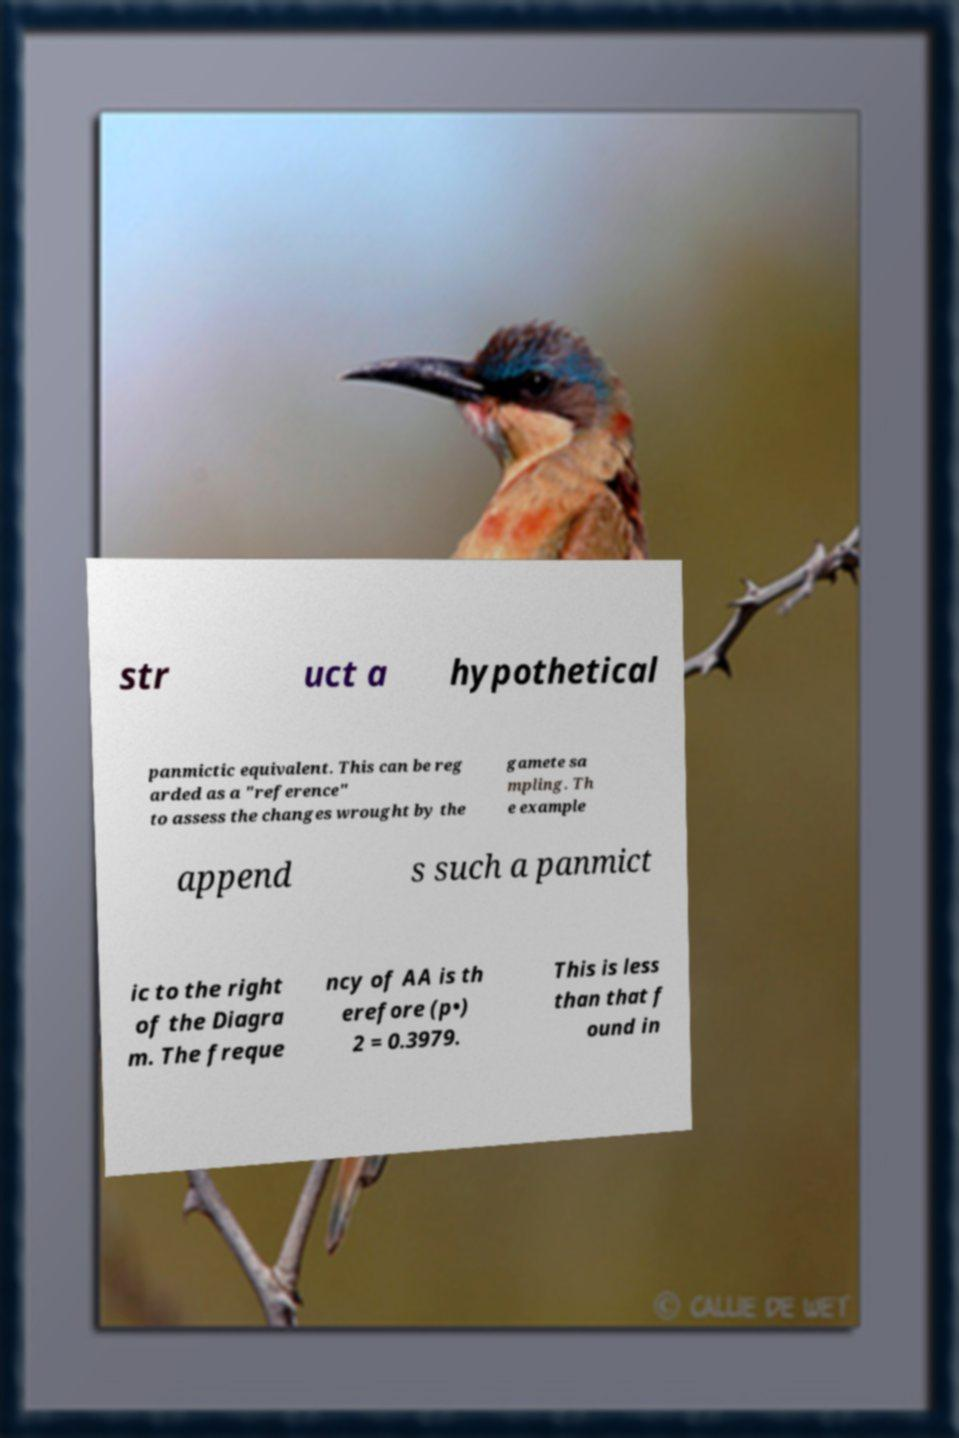Can you read and provide the text displayed in the image?This photo seems to have some interesting text. Can you extract and type it out for me? str uct a hypothetical panmictic equivalent. This can be reg arded as a "reference" to assess the changes wrought by the gamete sa mpling. Th e example append s such a panmict ic to the right of the Diagra m. The freque ncy of AA is th erefore (p•) 2 = 0.3979. This is less than that f ound in 